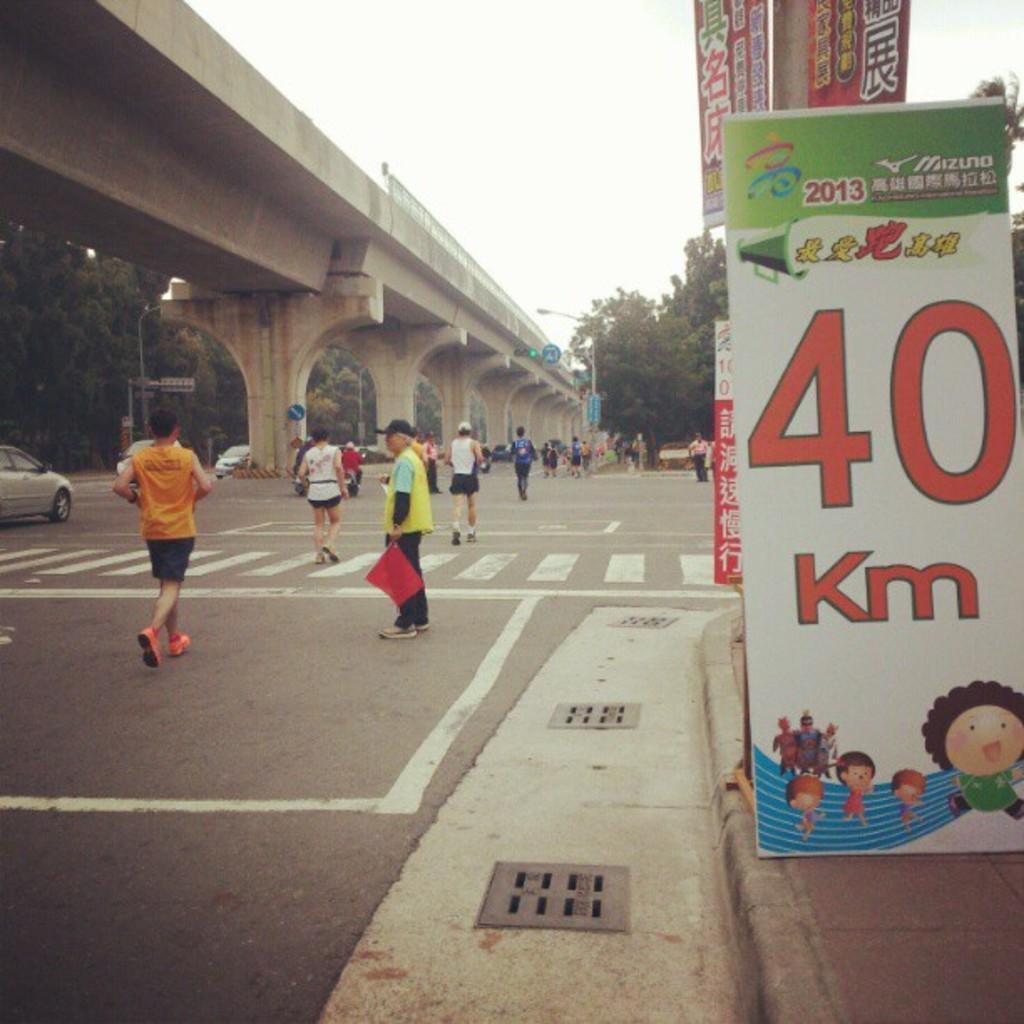Could you give a brief overview of what you see in this image? In this picture there are people and we can see boards, flyover, pillars, vehicles on the road, traffic signal and poles. In the background of the image we can see trees and sky. 